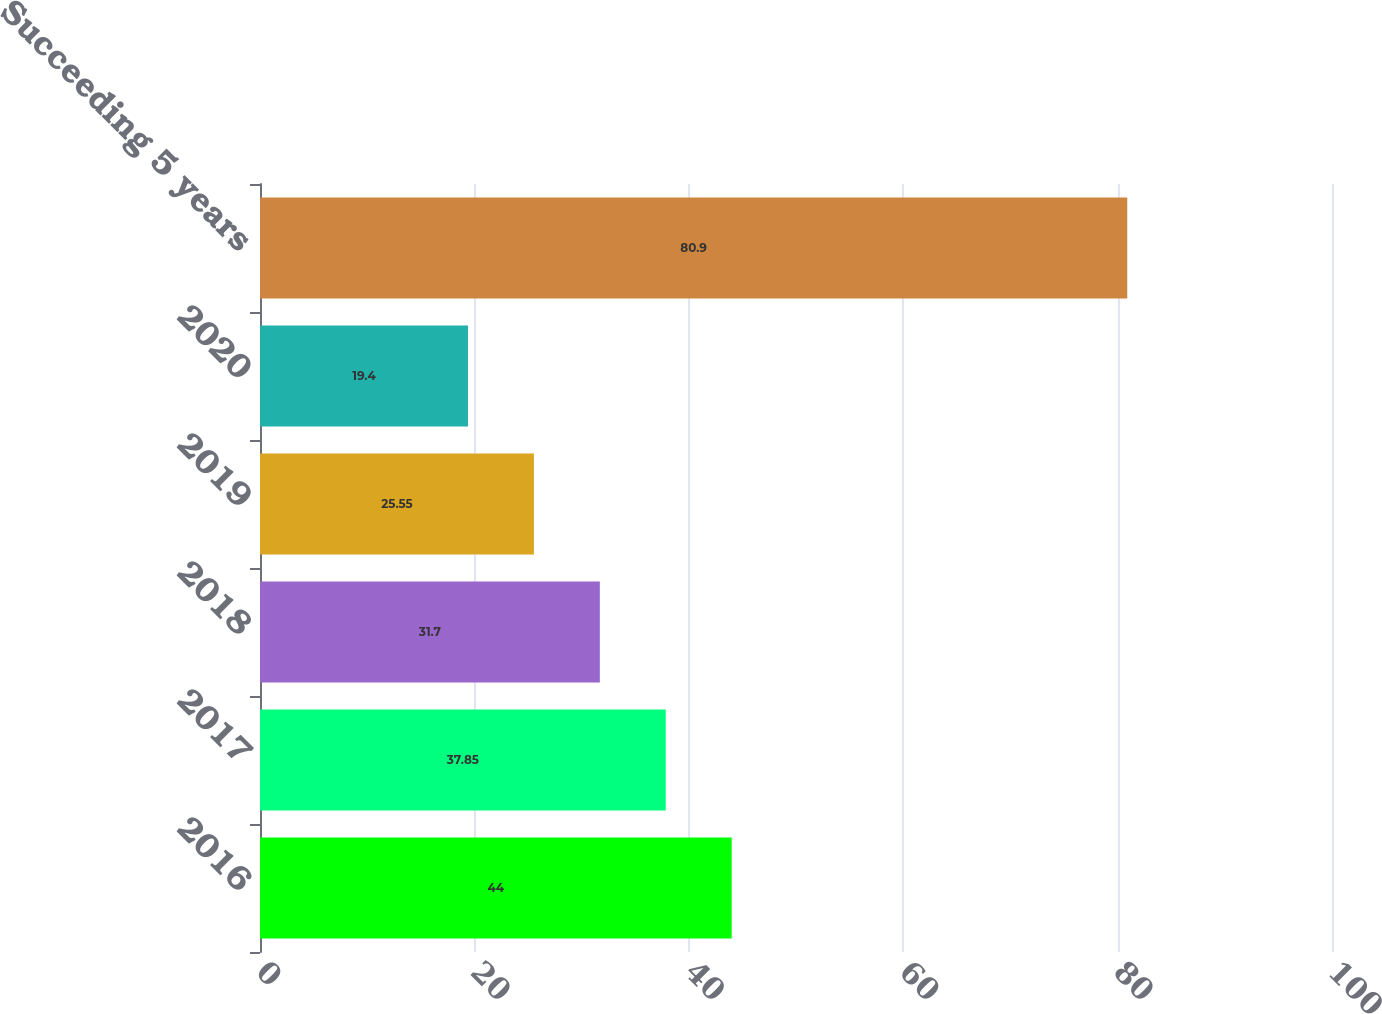Convert chart. <chart><loc_0><loc_0><loc_500><loc_500><bar_chart><fcel>2016<fcel>2017<fcel>2018<fcel>2019<fcel>2020<fcel>Succeeding 5 years<nl><fcel>44<fcel>37.85<fcel>31.7<fcel>25.55<fcel>19.4<fcel>80.9<nl></chart> 